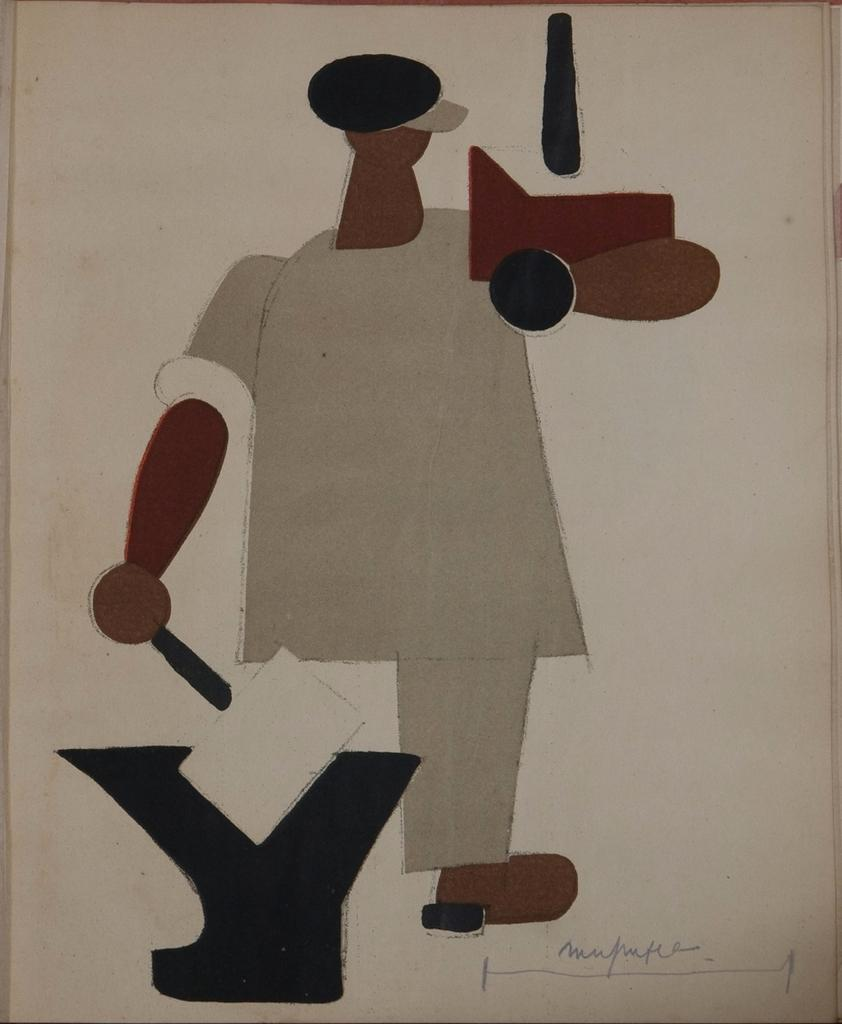What is featured in the image? There is a poster in the image. What is depicted on the poster? The poster has a painting of a person. Is there any text present in the image? Yes, there is text at the bottom of the image. What type of destruction can be seen happening to the doll in the image? There is no doll present in the image, and therefore no destruction can be observed. 